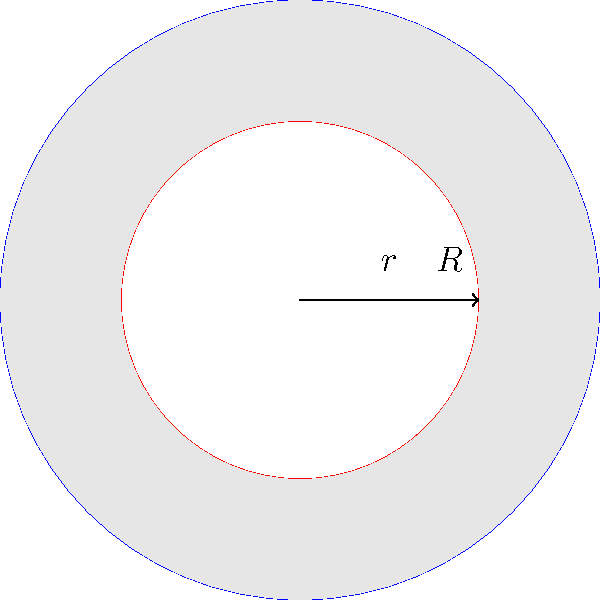As a research scientist, you are analyzing the structural properties of a novel nanomaterial. The material consists of concentric circular layers. The outer layer has a radius $R = 5$ nm, while the inner layer has a radius $r = 3$ nm. Calculate the area of the region between these two layers, expressing your result in square nanometers (nm²) to two decimal places. How might this information be relevant to the material's properties? Let's approach this step-by-step:

1) The area between two concentric circles is given by the difference of the areas of the larger and smaller circles.

2) The area of a circle is given by the formula $A = \pi r^2$, where $r$ is the radius.

3) For the outer circle:
   $A_{\text{outer}} = \pi R^2 = \pi (5\text{ nm})^2 = 25\pi \text{ nm}^2$

4) For the inner circle:
   $A_{\text{inner}} = \pi r^2 = \pi (3\text{ nm})^2 = 9\pi \text{ nm}^2$

5) The area between the circles is:
   $A_{\text{between}} = A_{\text{outer}} - A_{\text{inner}} = 25\pi \text{ nm}^2 - 9\pi \text{ nm}^2 = 16\pi \text{ nm}^2$

6) Calculating this:
   $16\pi \approx 50.27 \text{ nm}^2$

7) Rounding to two decimal places:
   $50.27 \text{ nm}^2 \approx 50.27 \text{ nm}^2$

This area could be crucial in determining the material's properties such as its surface area-to-volume ratio, which can affect reactivity, adsorption properties, and potentially its electrical or thermal conductivity. The precise measurement and reporting of such structural details are essential in materials science research for reproducibility and accurate characterization of novel nanomaterials.
Answer: $50.27 \text{ nm}^2$ 